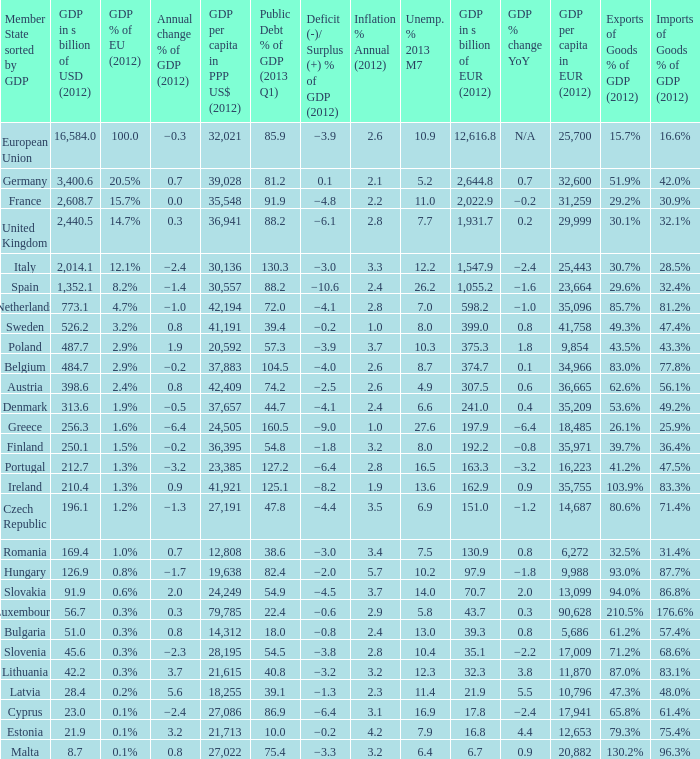What is the largest inflation % annual in 2012 of the country with a public debt % of GDP in 2013 Q1 greater than 88.2 and a GDP % of EU in 2012 of 2.9%? 2.6. 